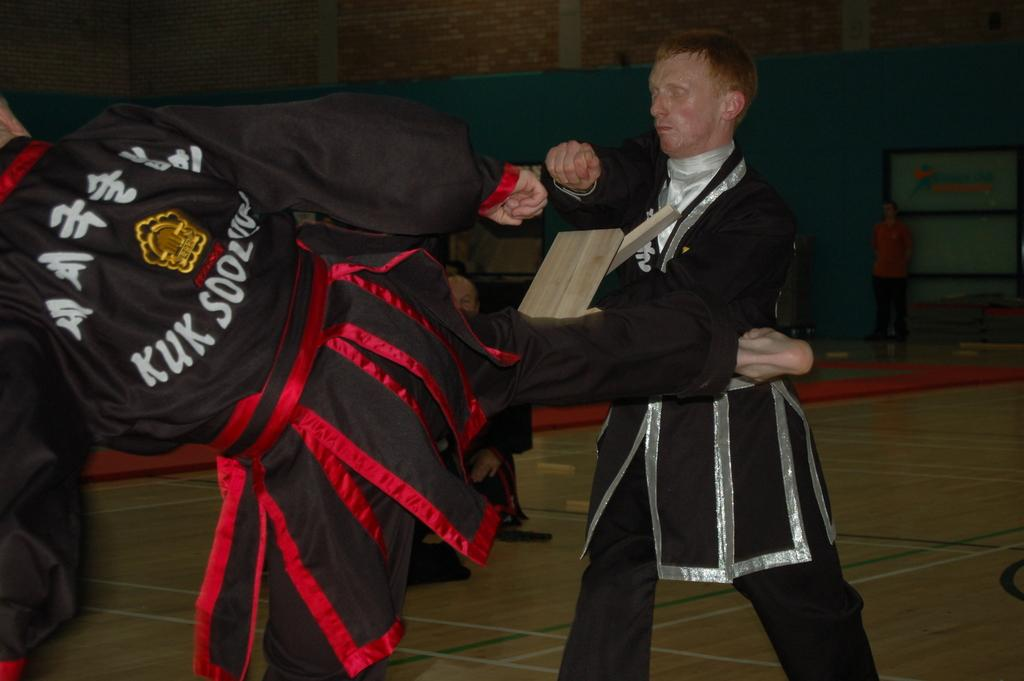<image>
Provide a brief description of the given image. the letters kuk are on the back of the person's shirt 